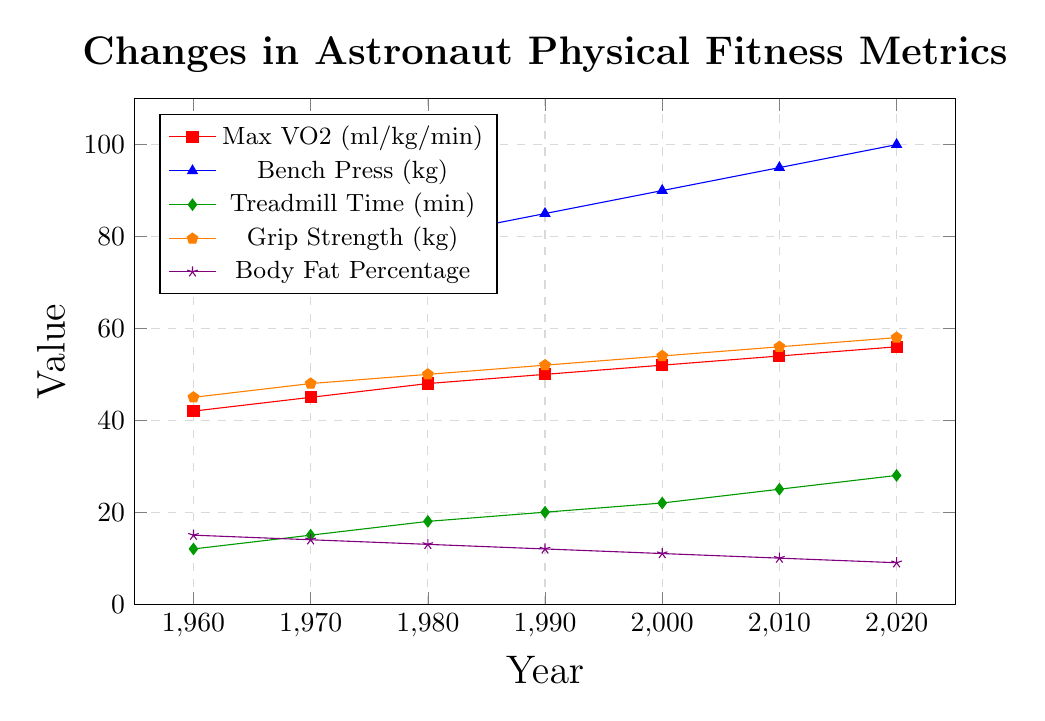Which metric had the highest increase from 1960 to 2020? To find the metric with the highest increase, we need to calculate the difference between 2020 and 1960 values for each metric and compare them. Max VO2 increased by 14 (56 - 42), Bench Press increased by 30 (100 - 70), Treadmill Time increased by 16 (28 - 12), Grip Strength increased by 13 (58 - 45), and Body Fat Percentage decreased by 6 (9 - 15). Bench Press had the highest increase.
Answer: Bench Press What is the trend in Body Fat Percentage from 1960 to 2020? By analyzing the line representing Body Fat Percentage, we can see that it consistently decreases over the years, starting from 15% in 1960 and reducing to 9% in 2020.
Answer: Decreasing Which metric had the smallest change over the decades? To find the smallest change, calculate the difference between 2020 and 1960 values for each metric and compare them. Body Fat Percentage changed by 6 (15 - 9), which is smaller than the changes in Max VO2, Bench Press, Treadmill Time, and Grip Strength.
Answer: Body Fat Percentage How does the change in Grip Strength compare to the change in Treadmill Time from 1960 to 2020? Calculate the difference for each metric: Grip Strength increased by 13 (58 - 45) and Treadmill Time increased by 16 (28 - 12). Therefore, Treadmill Time increased by more than Grip Strength.
Answer: Treadmill Time increased more From which year did the Bench Press metric start increasing by 5 kg per decade? Look for the differences in the Bench Press metric: 70 kg (1960), 75 kg (1970), 80 kg (1980). The consistent 5 kg increase starts from 1970.
Answer: 1970 What is the difference between Grip Strength and Max VO2 in 2020? Check the values for both metrics in 2020: Grip Strength (58 kg) and Max VO2 (56 ml/kg/min). Then calculate the difference: 58 - 56.
Answer: 2 Which color represents the Treadmill Time metric, and how much did it change from 1960 to 1990? The plot legend shows Treadmill Time has a green line with diamond markers. The values in 1960 and 1990 are 12 and 20 minutes, respectively, so the change is 20 - 12.
Answer: Green, 8 minutes Between 1980 and 1990, which metric had the largest relative increase? Calculate the relative increase for each metric: Max VO2 from 48 to 50 (4.17%), Bench Press from 80 to 85 (6.25%), Treadmill Time from 18 to 20 (11.11%), Grip Strength from 50 to 52 (4%), Body Fat Percentage from 13 to 12 (-7.69%). Treadmill Time had the largest relative increase.
Answer: Treadmill Time Calculate the average value of Grip Strength for the first and last years in the chart. Grip Strength is 45 in 1960 and 58 in 2020. The average is (45 + 58) / 2.
Answer: 51.5 